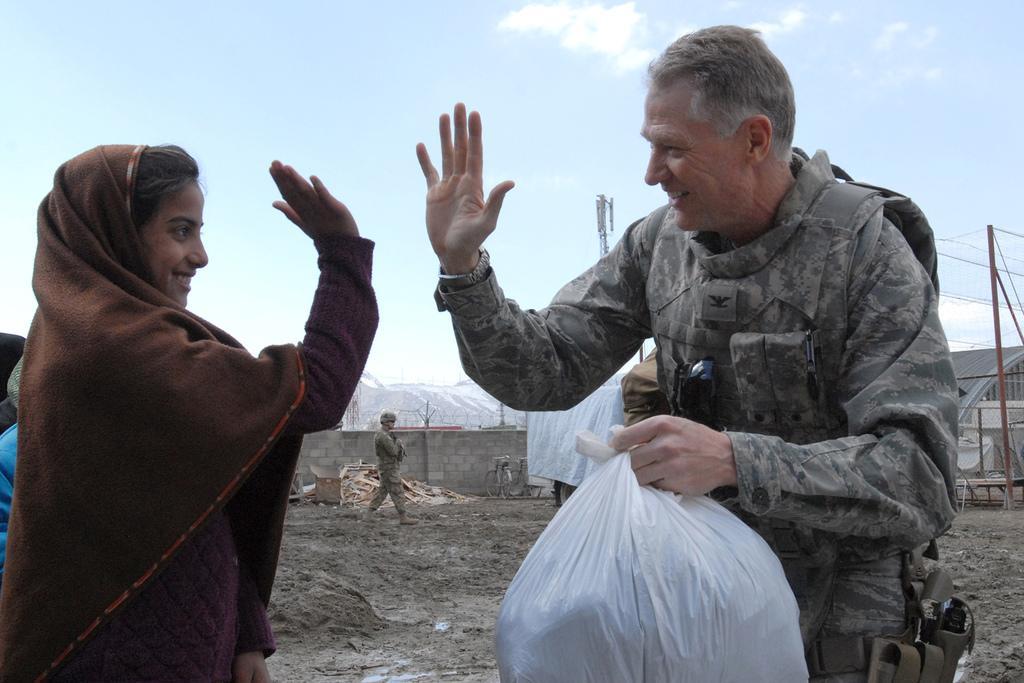Describe this image in one or two sentences. This picture shows a man and a woman giving high five and we see man carrying carry bag in his hand and we see another man walking and we see a blue cloudy Sky. 